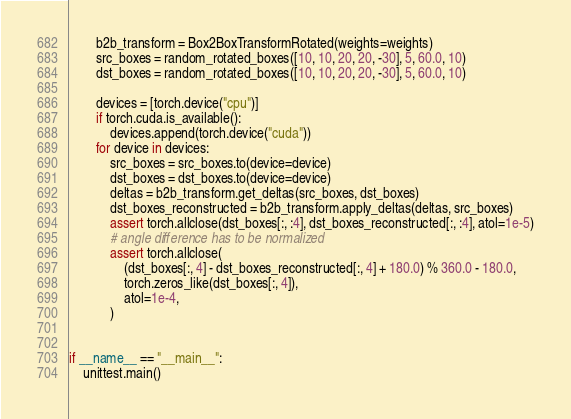Convert code to text. <code><loc_0><loc_0><loc_500><loc_500><_Python_>        b2b_transform = Box2BoxTransformRotated(weights=weights)
        src_boxes = random_rotated_boxes([10, 10, 20, 20, -30], 5, 60.0, 10)
        dst_boxes = random_rotated_boxes([10, 10, 20, 20, -30], 5, 60.0, 10)

        devices = [torch.device("cpu")]
        if torch.cuda.is_available():
            devices.append(torch.device("cuda"))
        for device in devices:
            src_boxes = src_boxes.to(device=device)
            dst_boxes = dst_boxes.to(device=device)
            deltas = b2b_transform.get_deltas(src_boxes, dst_boxes)
            dst_boxes_reconstructed = b2b_transform.apply_deltas(deltas, src_boxes)
            assert torch.allclose(dst_boxes[:, :4], dst_boxes_reconstructed[:, :4], atol=1e-5)
            # angle difference has to be normalized
            assert torch.allclose(
                (dst_boxes[:, 4] - dst_boxes_reconstructed[:, 4] + 180.0) % 360.0 - 180.0,
                torch.zeros_like(dst_boxes[:, 4]),
                atol=1e-4,
            )


if __name__ == "__main__":
    unittest.main()
</code> 